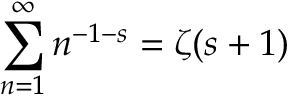<formula> <loc_0><loc_0><loc_500><loc_500>\sum _ { n = 1 } ^ { \infty } n ^ { - 1 - s } = \zeta ( s + 1 )</formula> 